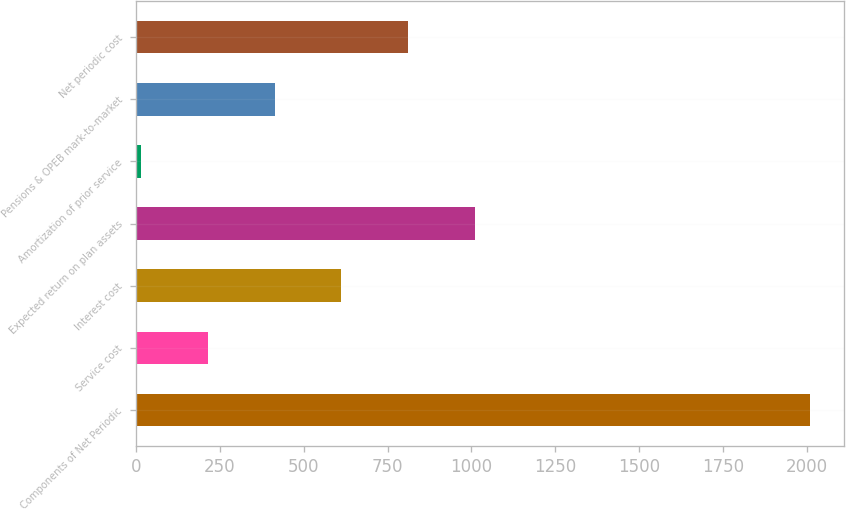<chart> <loc_0><loc_0><loc_500><loc_500><bar_chart><fcel>Components of Net Periodic<fcel>Service cost<fcel>Interest cost<fcel>Expected return on plan assets<fcel>Amortization of prior service<fcel>Pensions & OPEB mark-to-market<fcel>Net periodic cost<nl><fcel>2010<fcel>212.7<fcel>612.1<fcel>1011.5<fcel>13<fcel>412.4<fcel>811.8<nl></chart> 